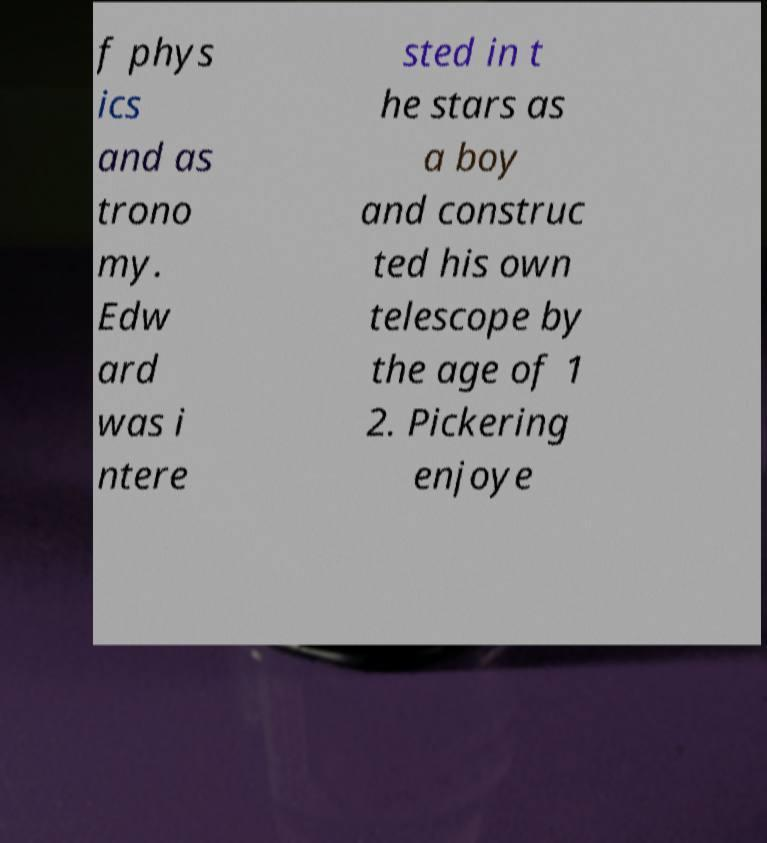Can you accurately transcribe the text from the provided image for me? f phys ics and as trono my. Edw ard was i ntere sted in t he stars as a boy and construc ted his own telescope by the age of 1 2. Pickering enjoye 